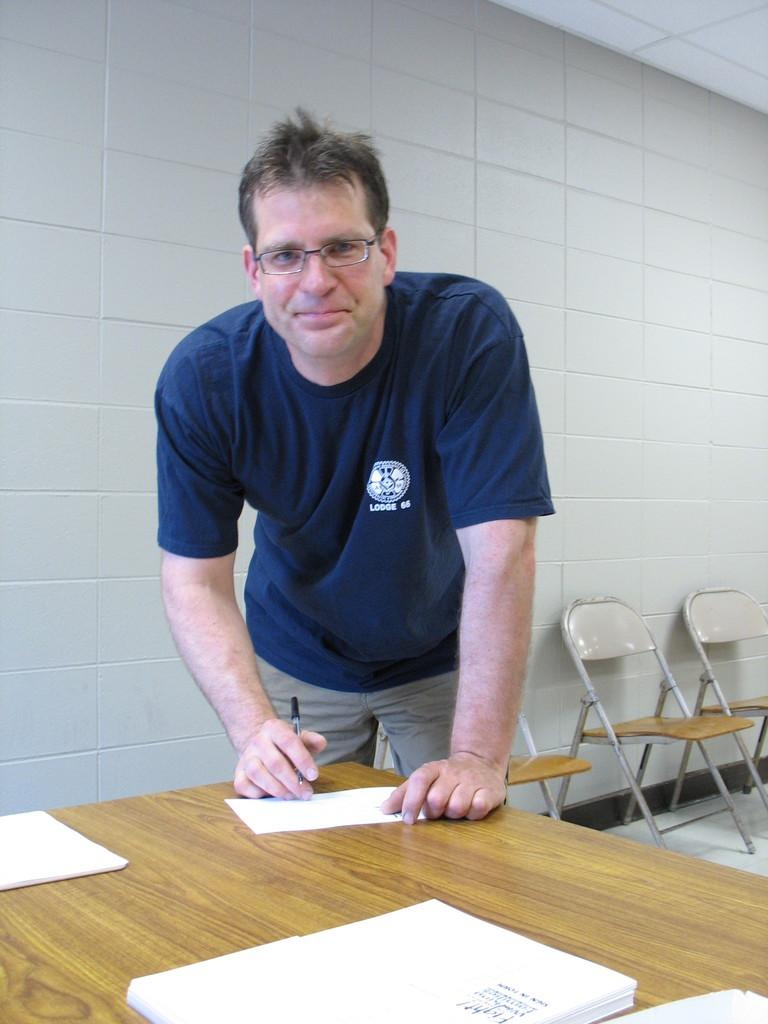<image>
Give a short and clear explanation of the subsequent image. A man wearing a blue shirt reading LODGE 66 writes a note. 